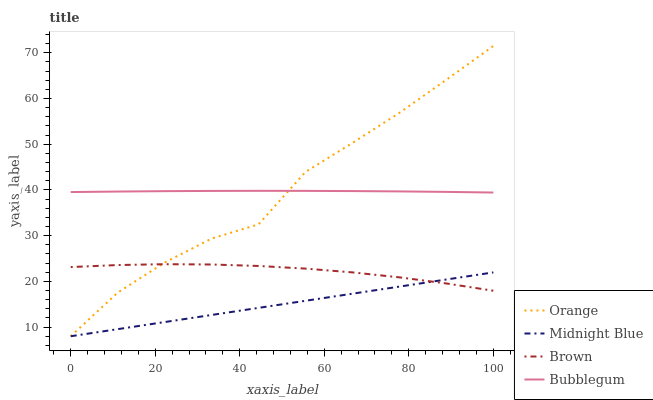Does Midnight Blue have the minimum area under the curve?
Answer yes or no. Yes. Does Orange have the maximum area under the curve?
Answer yes or no. Yes. Does Brown have the minimum area under the curve?
Answer yes or no. No. Does Brown have the maximum area under the curve?
Answer yes or no. No. Is Midnight Blue the smoothest?
Answer yes or no. Yes. Is Orange the roughest?
Answer yes or no. Yes. Is Brown the smoothest?
Answer yes or no. No. Is Brown the roughest?
Answer yes or no. No. Does Orange have the lowest value?
Answer yes or no. Yes. Does Brown have the lowest value?
Answer yes or no. No. Does Orange have the highest value?
Answer yes or no. Yes. Does Brown have the highest value?
Answer yes or no. No. Is Brown less than Bubblegum?
Answer yes or no. Yes. Is Bubblegum greater than Brown?
Answer yes or no. Yes. Does Midnight Blue intersect Brown?
Answer yes or no. Yes. Is Midnight Blue less than Brown?
Answer yes or no. No. Is Midnight Blue greater than Brown?
Answer yes or no. No. Does Brown intersect Bubblegum?
Answer yes or no. No. 